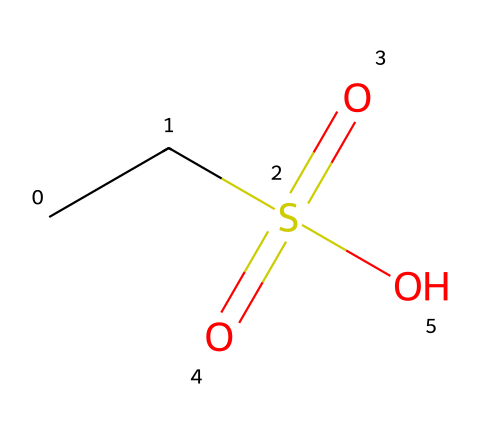What is the name of this chemical? The given SMILES representation corresponds to a chemical structure that is known as methanesulfonic acid, which can be identified by recognizing the methyl group (CC) attached to the sulfur atom (S) and the sulfonic acid functional group (=(O)(=O)O).
Answer: methanesulfonic acid How many oxygen atoms are present in this compound? By examining the SMILES, we notice the presence of three oxygen atoms: two double-bonded to sulfur (shown as =O) and one that is part of the hydroxyl group (-O).
Answer: three What is the oxidation state of sulfur in this compound? The oxidation state of sulfur can be determined by considering its bonds: it is bonded to two double-bonded oxygens and one single-bonded hydroxyl oxygen. Sulfur’s formal charge is calculated to be +6 (from its common valence of 6, subtracting the 4 bonds to more electronegative elements), indicating a high oxidation state.
Answer: +6 Is this compound considered acidic or basic? The presence of the sulfonic acid functional group (-SO3H) indicates the compound will donate protons in solution, thereby exhibiting acidic properties. This is a characteristic feature of all sulfonic acids.
Answer: acidic How many total bonds are formed between the sulfur atom and surrounding atoms? By analyzing the structure, we observe that sulfur is forming a total of four bonds: two double bonds with oxygen and one single bond with the hydroxyl group, alongside one bond to the carbon in the methyl group.
Answer: four 